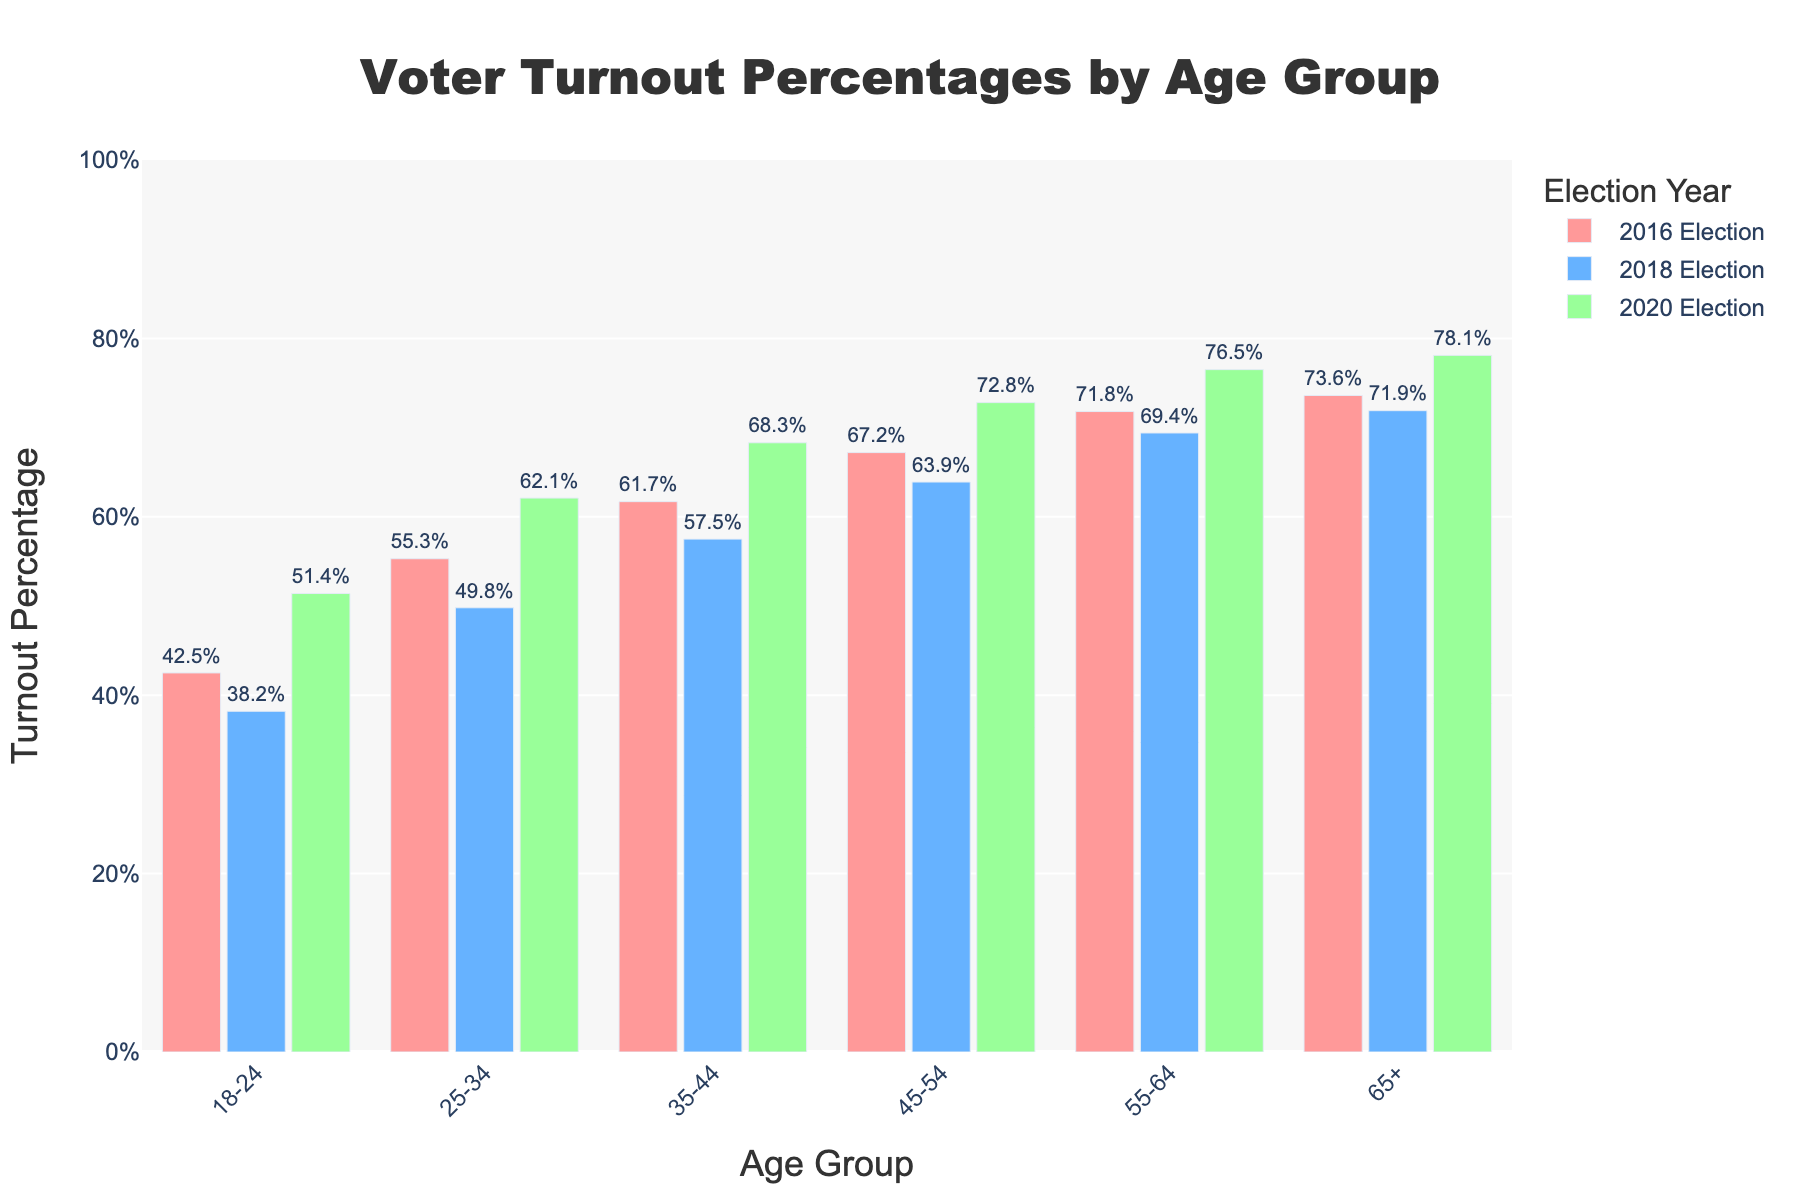Which age group had the highest voter turnout in the 2020 Election? Look at the bars representing the 2020 Election and identify the tallest one. The age group with the highest voter turnout in 2020 is 65+ with 78.1%.
Answer: 65+ Which age group saw the largest increase in voter turnout between the 2018 and 2020 Elections? Calculate the difference in voter turnout percentages between 2020 and 2018 for each age group. The 18-24 age group saw the largest increase: 51.4% - 38.2% = 13.2%.
Answer: 18-24 What is the average voter turnout for the 35-44 age group across the three elections? Sum the voter turnout percentages for the 35-44 age group across the three elections and divide by the number of elections (3). (61.7 + 57.5 + 68.3) / 3 = 62.5%.
Answer: 62.5% How did voter turnout in the 25-34 age group in the 2018 Election compare to the 2016 Election? Subtract the 2018 percentage for the 25-34 age group from the 2016 percentage. 55.3% - 49.8% = 5.5%.
Answer: 5.5% lower Which election year had the lowest overall voter turnout for the 55-64 age group? Compare the voter turnout percentages for the 55-64 age group across the three elections. The lowest turnout was in 2018 with 69.4%.
Answer: 2018 Between the 45-54 age group and the 55-64 age group, which saw a greater turnout in the 2016 Election? Compare the voter turnout percentages for these two age groups in 2016. The 55-64 age group had a voter turnout of 71.8% and the 45-54 age group had 67.2%, so 55-64 had the greater turnout.
Answer: 55-64 In which election did the 18-24 age group see its lowest voter turnout? Identify the shortest bar representing the 18-24 age group across the three election years. The lowest turnout was in the 2018 Election with 38.2%.
Answer: 2018 What is the total voter turnout for the 65+ age group across all three elections? Sum the voter turnout percentages for the 65+ age group across 2016, 2018, and 2020. 73.6 + 71.9 + 78.1 = 223.6%.
Answer: 223.6% Which age group had the smallest difference in voter turnout between the 2016 and 2020 Elections? Calculate the difference in voter turnout percentages between 2016 and 2020 for each age group and identify the smallest one. The 65+ age group had the smallest difference: 78.1% - 73.6% = 4.5%.
Answer: 65+ If you average the voter turnout of all age groups in each election year, which election year had the highest average turnout? First, find the average voter turnout for each election year by summing the percentages for all age groups and dividing by 6. For 2016, (42.5 + 55.3 + 61.7 + 67.2 + 71.8 + 73.6) / 6 = 62.35%. For 2018, (38.2 + 49.8 + 57.5 + 63.9 + 69.4 + 71.9) / 6 = 58.45%. For 2020, (51.4 + 62.1 + 68.3 + 72.8 + 76.5 + 78.1) / 6 = 68.2%. So, 2020 had the highest average turnout.
Answer: 2020 